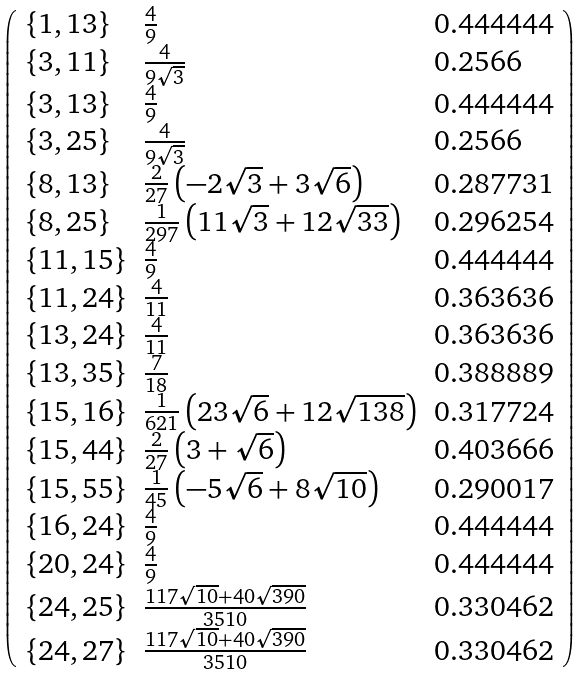<formula> <loc_0><loc_0><loc_500><loc_500>\left ( \begin{array} { l l l } \{ 1 , 1 3 \} & \frac { 4 } { 9 } & 0 . 4 4 4 4 4 4 \\ \{ 3 , 1 1 \} & \frac { 4 } { 9 \sqrt { 3 } } & 0 . 2 5 6 6 \\ \{ 3 , 1 3 \} & \frac { 4 } { 9 } & 0 . 4 4 4 4 4 4 \\ \{ 3 , 2 5 \} & \frac { 4 } { 9 \sqrt { 3 } } & 0 . 2 5 6 6 \\ \{ 8 , 1 3 \} & \frac { 2 } { 2 7 } \left ( - 2 \sqrt { 3 } + 3 \sqrt { 6 } \right ) & 0 . 2 8 7 7 3 1 \\ \{ 8 , 2 5 \} & \frac { 1 } { 2 9 7 } \left ( 1 1 \sqrt { 3 } + 1 2 \sqrt { 3 3 } \right ) & 0 . 2 9 6 2 5 4 \\ \{ 1 1 , 1 5 \} & \frac { 4 } { 9 } & 0 . 4 4 4 4 4 4 \\ \{ 1 1 , 2 4 \} & \frac { 4 } { 1 1 } & 0 . 3 6 3 6 3 6 \\ \{ 1 3 , 2 4 \} & \frac { 4 } { 1 1 } & 0 . 3 6 3 6 3 6 \\ \{ 1 3 , 3 5 \} & \frac { 7 } { 1 8 } & 0 . 3 8 8 8 8 9 \\ \{ 1 5 , 1 6 \} & \frac { 1 } { 6 2 1 } \left ( 2 3 \sqrt { 6 } + 1 2 \sqrt { 1 3 8 } \right ) & 0 . 3 1 7 7 2 4 \\ \{ 1 5 , 4 4 \} & \frac { 2 } { 2 7 } \left ( 3 + \sqrt { 6 } \right ) & 0 . 4 0 3 6 6 6 \\ \{ 1 5 , 5 5 \} & \frac { 1 } { 4 5 } \left ( - 5 \sqrt { 6 } + 8 \sqrt { 1 0 } \right ) & 0 . 2 9 0 0 1 7 \\ \{ 1 6 , 2 4 \} & \frac { 4 } { 9 } & 0 . 4 4 4 4 4 4 \\ \{ 2 0 , 2 4 \} & \frac { 4 } { 9 } & 0 . 4 4 4 4 4 4 \\ \{ 2 4 , 2 5 \} & \frac { 1 1 7 \sqrt { 1 0 } + 4 0 \sqrt { 3 9 0 } } { 3 5 1 0 } & 0 . 3 3 0 4 6 2 \\ \{ 2 4 , 2 7 \} & \frac { 1 1 7 \sqrt { 1 0 } + 4 0 \sqrt { 3 9 0 } } { 3 5 1 0 } & 0 . 3 3 0 4 6 2 \end{array} \right )</formula> 